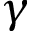<formula> <loc_0><loc_0><loc_500><loc_500>\gamma</formula> 